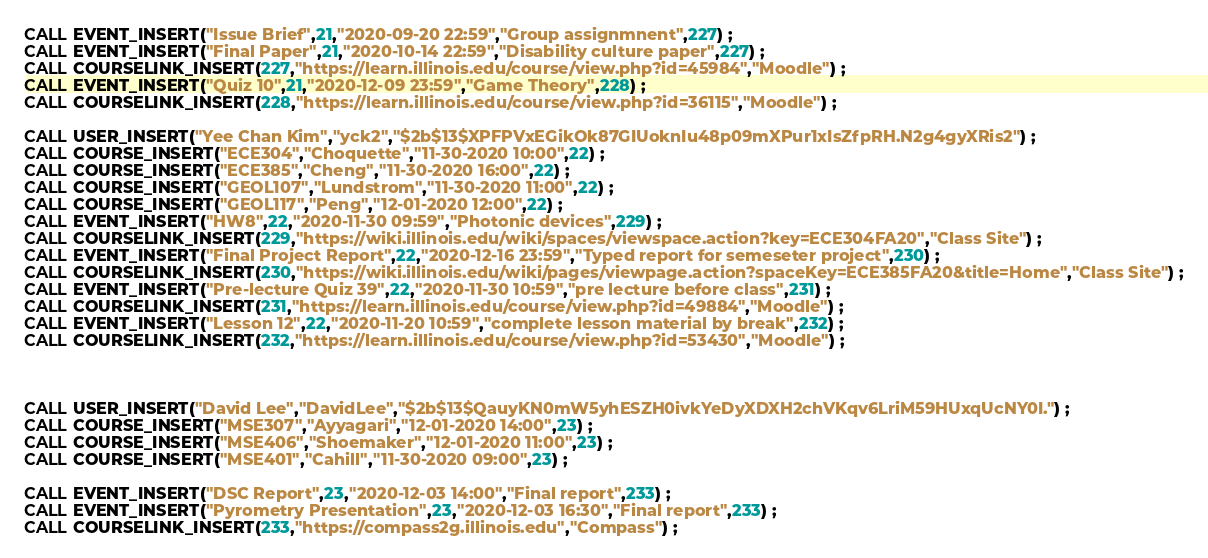Convert code to text. <code><loc_0><loc_0><loc_500><loc_500><_SQL_>CALL EVENT_INSERT("Issue Brief",21,"2020-09-20 22:59","Group assignmnent",227) ;
CALL EVENT_INSERT("Final Paper",21,"2020-10-14 22:59","Disability culture paper",227) ;
CALL COURSELINK_INSERT(227,"https://learn.illinois.edu/course/view.php?id=45984","Moodle") ;
CALL EVENT_INSERT("Quiz 10",21,"2020-12-09 23:59","Game Theory",228) ;
CALL COURSELINK_INSERT(228,"https://learn.illinois.edu/course/view.php?id=36115","Moodle") ;

CALL USER_INSERT("Yee Chan Kim","yck2","$2b$13$XPFPVxEGikOk87GIUoknIu48p09mXPur1xIsZfpRH.N2g4gyXRis2") ;
CALL COURSE_INSERT("ECE304","Choquette","11-30-2020 10:00",22) ;
CALL COURSE_INSERT("ECE385","Cheng","11-30-2020 16:00",22) ;
CALL COURSE_INSERT("GEOL107","Lundstrom","11-30-2020 11:00",22) ;
CALL COURSE_INSERT("GEOL117","Peng","12-01-2020 12:00",22) ;
CALL EVENT_INSERT("HW8",22,"2020-11-30 09:59","Photonic devices",229) ;
CALL COURSELINK_INSERT(229,"https://wiki.illinois.edu/wiki/spaces/viewspace.action?key=ECE304FA20","Class Site") ;
CALL EVENT_INSERT("Final Project Report",22,"2020-12-16 23:59","Typed report for semeseter project",230) ;
CALL COURSELINK_INSERT(230,"https://wiki.illinois.edu/wiki/pages/viewpage.action?spaceKey=ECE385FA20&title=Home","Class Site") ;
CALL EVENT_INSERT("Pre-lecture Quiz 39",22,"2020-11-30 10:59","pre lecture before class",231) ;
CALL COURSELINK_INSERT(231,"https://learn.illinois.edu/course/view.php?id=49884","Moodle") ;
CALL EVENT_INSERT("Lesson 12",22,"2020-11-20 10:59","complete lesson material by break",232) ;
CALL COURSELINK_INSERT(232,"https://learn.illinois.edu/course/view.php?id=53430","Moodle") ;



CALL USER_INSERT("David Lee","DavidLee","$2b$13$QauyKN0mW5yhESZH0ivkYeDyXDXH2chVKqv6LriM59HUxqUcNY0I.") ;
CALL COURSE_INSERT("MSE307","Ayyagari","12-01-2020 14:00",23) ;
CALL COURSE_INSERT("MSE406","Shoemaker","12-01-2020 11:00",23) ;
CALL COURSE_INSERT("MSE401","Cahill","11-30-2020 09:00",23) ;

CALL EVENT_INSERT("DSC Report",23,"2020-12-03 14:00","Final report",233) ;
CALL EVENT_INSERT("Pyrometry Presentation",23,"2020-12-03 16:30","Final report",233) ;
CALL COURSELINK_INSERT(233,"https://compass2g.illinois.edu","Compass") ;
</code> 